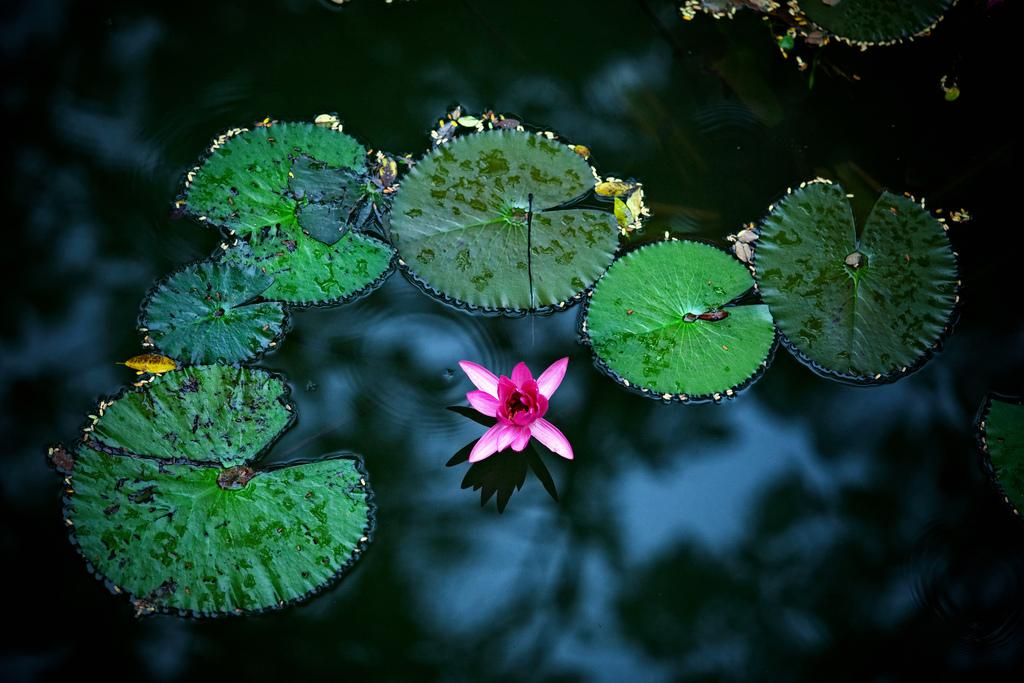What is the main subject of the image? There is a flower in the image. Where is the flower located? The flower is in the water. What else can be seen in the image besides the flower? There are green leaves visible in the image. What is the color of the flower? The flower is pink in color. Can you tell me how many people are playing chess in the image? There is no chess game or people present in the image; it features a pink flower in the water with green leaves. Is there a feather visible in the image? There is no feather present in the image. 